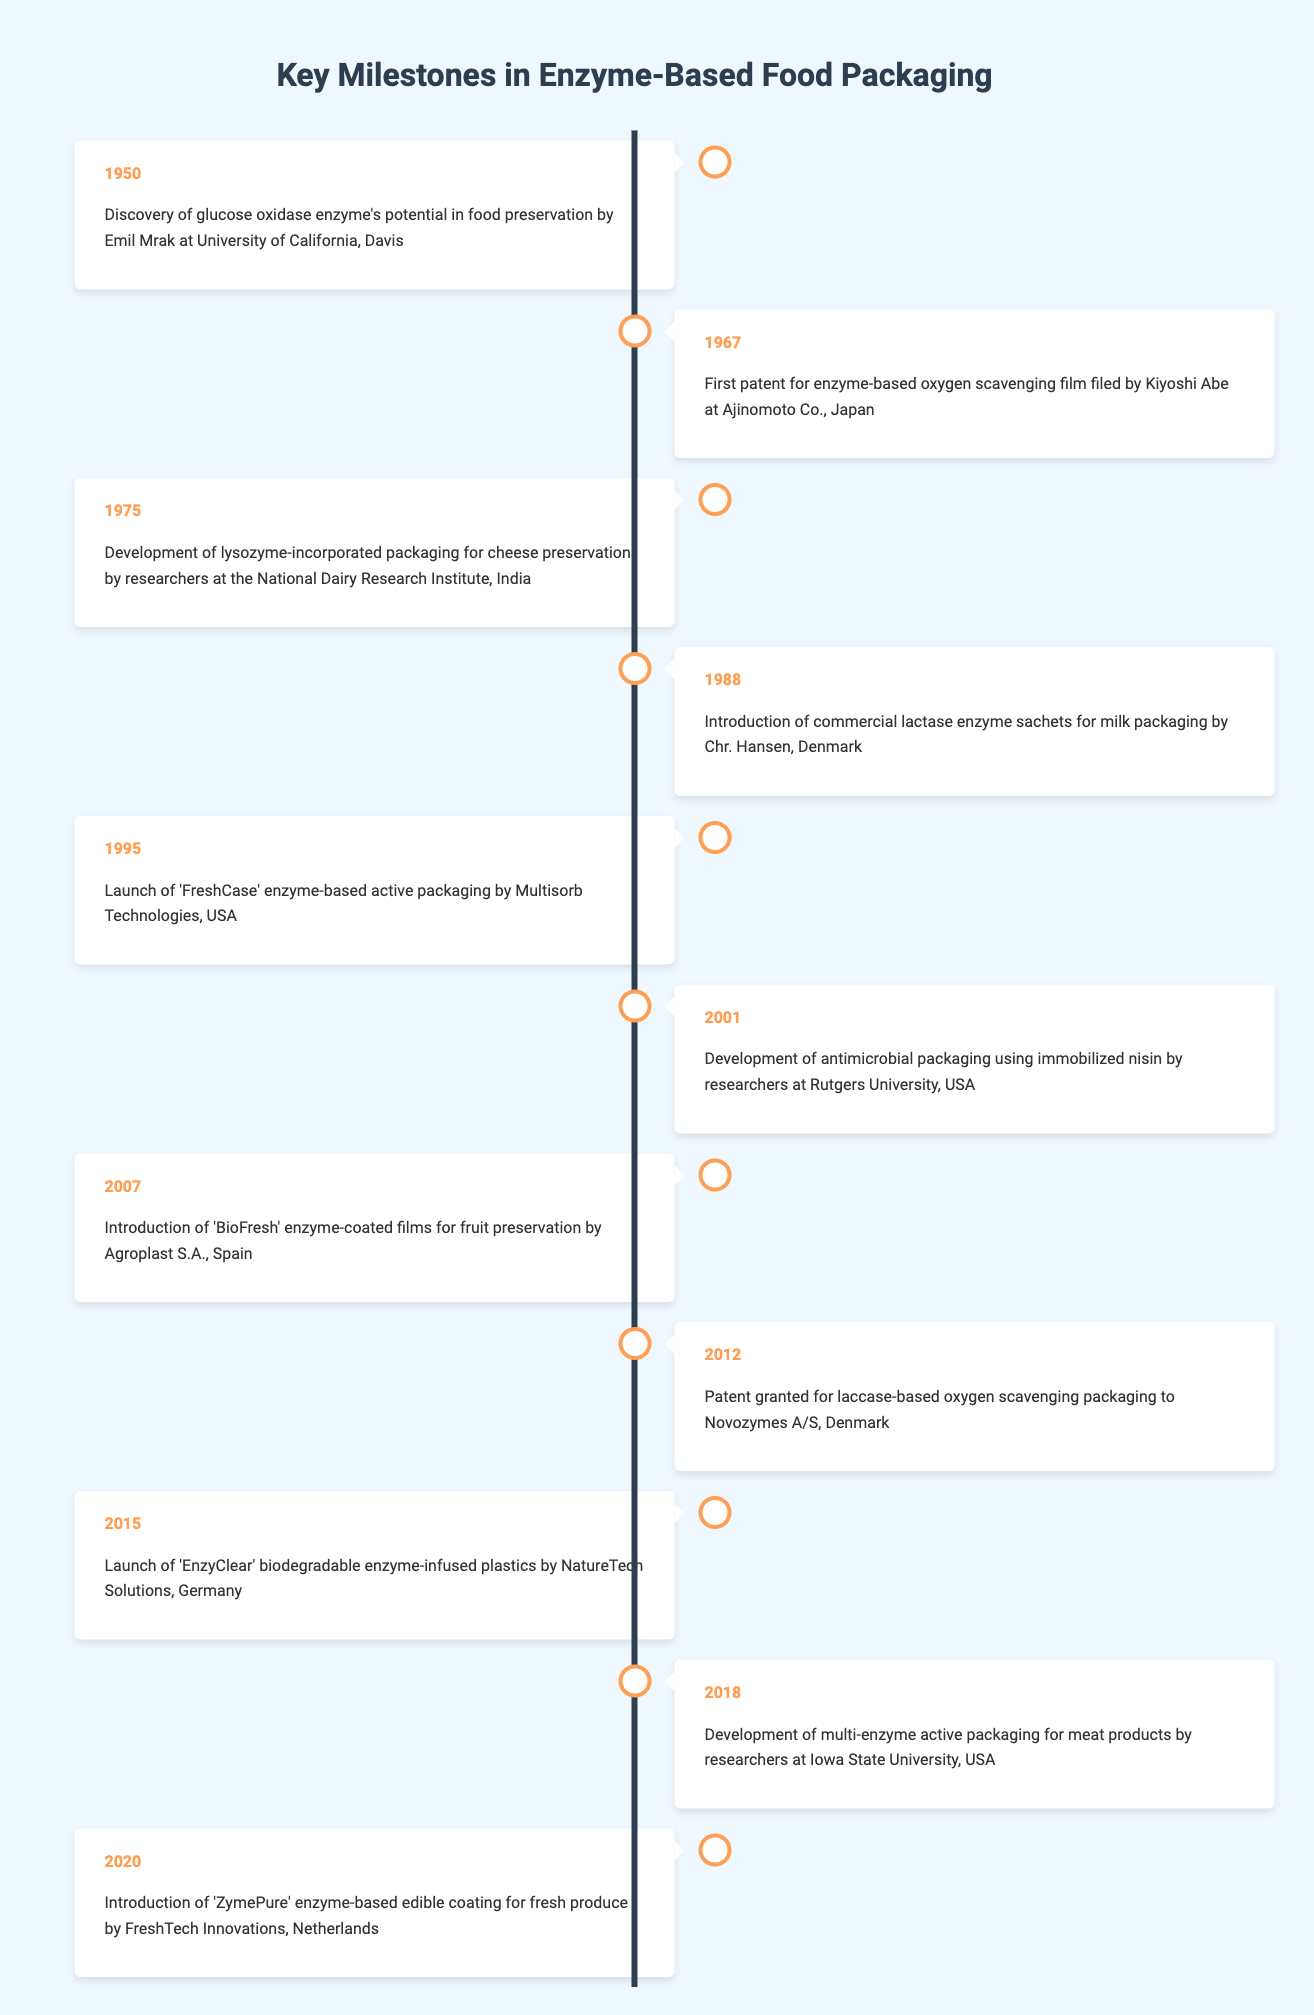What year was the first patent for enzyme-based oxygen scavenging film filed? The table lists the event from 1967 along with the associated milestone, confirming that the first patent for enzyme-based oxygen scavenging film was filed in that year.
Answer: 1967 Who developed the first packaging using lysozyme for cheese preservation? According to the table, the researchers at the National Dairy Research Institute in India are credited with the development of lysozyme-incorporated packaging for cheese preservation in 1975.
Answer: Researchers at the National Dairy Research Institute, India How many milestone events occurred in the 2000s? The table lists three events: in 2001, 2007, and 2012, which indicates that three milestone events took place during that decade.
Answer: 3 Was the introduction of 'ZymePure' enzyme-based edible coating for fresh produce the earliest milestone in the timeline? Examining the years listed, the earliest event is from 1950, which predates the introduction of 'ZymePure' in 2020, confirming the statement is false.
Answer: No Which enzyme was commonly associated with packaging for milk in 1988? The table specifies the introduction of commercial lactase enzyme sachets for milk packaging by Chr. Hansen in Denmark, clearly indicating lactase's association.
Answer: Lactase What is the difference in years between the discovery of glucose oxidase and the launch of 'EnzyClear'? Glucose oxidase was discovered in 1950 and 'EnzyClear' was launched in 2015. Therefore, the difference is 2015 - 1950 = 65 years.
Answer: 65 years Which year marks the introduction of enzyme-coated films for fruit preservation? The table shows that 'BioFresh', enzyme-coated films for fruit preservation, were introduced in 2007.
Answer: 2007 What is the average year of the events listed in the 2010s? The events in the 2010s are from 2012, 2015, and 2018. The average year is calculated as (2012 + 2015 + 2018) / 3 = 2015.
Answer: 2015 What type of packaging was developed using immobilized nisin in 2001? The table indicates that in 2001, antimicrobial packaging was developed using immobilized nisin by researchers at Rutgers University in the USA.
Answer: Antimicrobial packaging 